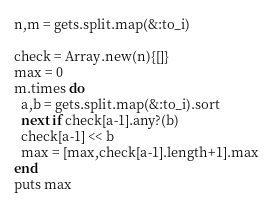<code> <loc_0><loc_0><loc_500><loc_500><_Ruby_>n,m = gets.split.map(&:to_i)

check = Array.new(n){[]}
max = 0
m.times do
  a,b = gets.split.map(&:to_i).sort
  next if check[a-1].any?(b)
  check[a-1] << b
  max = [max,check[a-1].length+1].max
end
puts max
</code> 